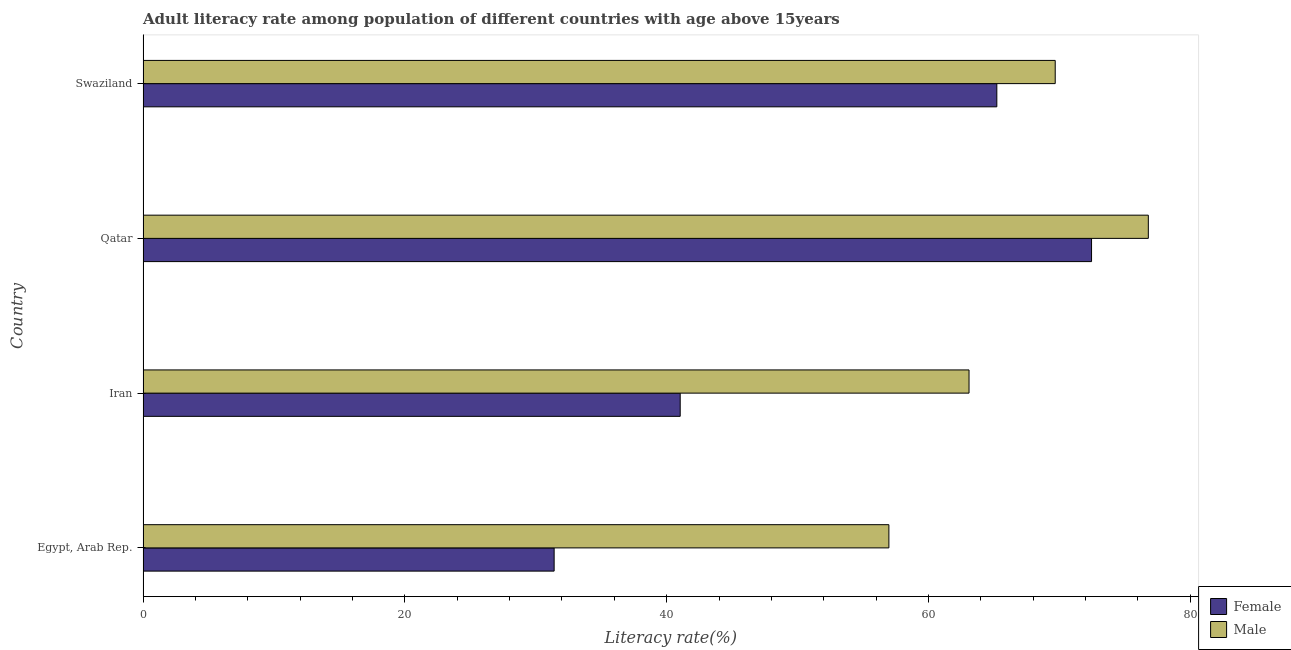How many groups of bars are there?
Your answer should be very brief. 4. Are the number of bars per tick equal to the number of legend labels?
Give a very brief answer. Yes. Are the number of bars on each tick of the Y-axis equal?
Your answer should be very brief. Yes. How many bars are there on the 3rd tick from the top?
Provide a short and direct response. 2. What is the label of the 1st group of bars from the top?
Make the answer very short. Swaziland. In how many cases, is the number of bars for a given country not equal to the number of legend labels?
Your answer should be very brief. 0. What is the female adult literacy rate in Qatar?
Your answer should be compact. 72.46. Across all countries, what is the maximum male adult literacy rate?
Provide a short and direct response. 76.8. Across all countries, what is the minimum female adult literacy rate?
Your answer should be very brief. 31.4. In which country was the female adult literacy rate maximum?
Your answer should be compact. Qatar. In which country was the male adult literacy rate minimum?
Make the answer very short. Egypt, Arab Rep. What is the total female adult literacy rate in the graph?
Provide a short and direct response. 210.12. What is the difference between the male adult literacy rate in Iran and that in Qatar?
Give a very brief answer. -13.7. What is the difference between the male adult literacy rate in Iran and the female adult literacy rate in Egypt, Arab Rep.?
Ensure brevity in your answer.  31.7. What is the average female adult literacy rate per country?
Provide a succinct answer. 52.53. What is the difference between the female adult literacy rate and male adult literacy rate in Iran?
Make the answer very short. -22.07. What is the ratio of the male adult literacy rate in Egypt, Arab Rep. to that in Swaziland?
Offer a very short reply. 0.82. Is the female adult literacy rate in Egypt, Arab Rep. less than that in Iran?
Your answer should be compact. Yes. Is the difference between the female adult literacy rate in Egypt, Arab Rep. and Qatar greater than the difference between the male adult literacy rate in Egypt, Arab Rep. and Qatar?
Offer a terse response. No. What is the difference between the highest and the second highest female adult literacy rate?
Offer a very short reply. 7.24. What is the difference between the highest and the lowest female adult literacy rate?
Offer a terse response. 41.05. In how many countries, is the female adult literacy rate greater than the average female adult literacy rate taken over all countries?
Your response must be concise. 2. What does the 1st bar from the bottom in Swaziland represents?
Provide a short and direct response. Female. How many bars are there?
Provide a succinct answer. 8. Are all the bars in the graph horizontal?
Make the answer very short. Yes. How many countries are there in the graph?
Make the answer very short. 4. What is the difference between two consecutive major ticks on the X-axis?
Keep it short and to the point. 20. Are the values on the major ticks of X-axis written in scientific E-notation?
Offer a terse response. No. Does the graph contain any zero values?
Provide a succinct answer. No. Does the graph contain grids?
Your answer should be compact. No. Where does the legend appear in the graph?
Give a very brief answer. Bottom right. How are the legend labels stacked?
Offer a very short reply. Vertical. What is the title of the graph?
Provide a short and direct response. Adult literacy rate among population of different countries with age above 15years. Does "Merchandise exports" appear as one of the legend labels in the graph?
Your answer should be very brief. No. What is the label or title of the X-axis?
Your answer should be very brief. Literacy rate(%). What is the Literacy rate(%) of Female in Egypt, Arab Rep.?
Provide a short and direct response. 31.4. What is the Literacy rate(%) in Male in Egypt, Arab Rep.?
Provide a short and direct response. 56.98. What is the Literacy rate(%) in Female in Iran?
Your response must be concise. 41.03. What is the Literacy rate(%) of Male in Iran?
Offer a terse response. 63.1. What is the Literacy rate(%) in Female in Qatar?
Offer a very short reply. 72.46. What is the Literacy rate(%) of Male in Qatar?
Make the answer very short. 76.8. What is the Literacy rate(%) in Female in Swaziland?
Ensure brevity in your answer.  65.22. What is the Literacy rate(%) of Male in Swaziland?
Ensure brevity in your answer.  69.68. Across all countries, what is the maximum Literacy rate(%) in Female?
Offer a terse response. 72.46. Across all countries, what is the maximum Literacy rate(%) in Male?
Provide a succinct answer. 76.8. Across all countries, what is the minimum Literacy rate(%) in Female?
Provide a succinct answer. 31.4. Across all countries, what is the minimum Literacy rate(%) of Male?
Give a very brief answer. 56.98. What is the total Literacy rate(%) in Female in the graph?
Keep it short and to the point. 210.12. What is the total Literacy rate(%) of Male in the graph?
Offer a very short reply. 266.56. What is the difference between the Literacy rate(%) of Female in Egypt, Arab Rep. and that in Iran?
Your response must be concise. -9.63. What is the difference between the Literacy rate(%) of Male in Egypt, Arab Rep. and that in Iran?
Give a very brief answer. -6.12. What is the difference between the Literacy rate(%) of Female in Egypt, Arab Rep. and that in Qatar?
Your answer should be compact. -41.05. What is the difference between the Literacy rate(%) in Male in Egypt, Arab Rep. and that in Qatar?
Keep it short and to the point. -19.82. What is the difference between the Literacy rate(%) in Female in Egypt, Arab Rep. and that in Swaziland?
Give a very brief answer. -33.82. What is the difference between the Literacy rate(%) of Male in Egypt, Arab Rep. and that in Swaziland?
Keep it short and to the point. -12.71. What is the difference between the Literacy rate(%) in Female in Iran and that in Qatar?
Your answer should be compact. -31.43. What is the difference between the Literacy rate(%) of Male in Iran and that in Qatar?
Your answer should be compact. -13.7. What is the difference between the Literacy rate(%) in Female in Iran and that in Swaziland?
Give a very brief answer. -24.19. What is the difference between the Literacy rate(%) in Male in Iran and that in Swaziland?
Your response must be concise. -6.58. What is the difference between the Literacy rate(%) in Female in Qatar and that in Swaziland?
Your answer should be very brief. 7.24. What is the difference between the Literacy rate(%) of Male in Qatar and that in Swaziland?
Provide a succinct answer. 7.11. What is the difference between the Literacy rate(%) in Female in Egypt, Arab Rep. and the Literacy rate(%) in Male in Iran?
Make the answer very short. -31.7. What is the difference between the Literacy rate(%) of Female in Egypt, Arab Rep. and the Literacy rate(%) of Male in Qatar?
Provide a succinct answer. -45.39. What is the difference between the Literacy rate(%) in Female in Egypt, Arab Rep. and the Literacy rate(%) in Male in Swaziland?
Provide a short and direct response. -38.28. What is the difference between the Literacy rate(%) in Female in Iran and the Literacy rate(%) in Male in Qatar?
Keep it short and to the point. -35.76. What is the difference between the Literacy rate(%) of Female in Iran and the Literacy rate(%) of Male in Swaziland?
Provide a short and direct response. -28.65. What is the difference between the Literacy rate(%) in Female in Qatar and the Literacy rate(%) in Male in Swaziland?
Offer a terse response. 2.78. What is the average Literacy rate(%) of Female per country?
Your answer should be compact. 52.53. What is the average Literacy rate(%) of Male per country?
Your answer should be very brief. 66.64. What is the difference between the Literacy rate(%) of Female and Literacy rate(%) of Male in Egypt, Arab Rep.?
Your answer should be compact. -25.57. What is the difference between the Literacy rate(%) in Female and Literacy rate(%) in Male in Iran?
Provide a short and direct response. -22.07. What is the difference between the Literacy rate(%) in Female and Literacy rate(%) in Male in Qatar?
Your response must be concise. -4.34. What is the difference between the Literacy rate(%) in Female and Literacy rate(%) in Male in Swaziland?
Offer a terse response. -4.46. What is the ratio of the Literacy rate(%) in Female in Egypt, Arab Rep. to that in Iran?
Your answer should be compact. 0.77. What is the ratio of the Literacy rate(%) of Male in Egypt, Arab Rep. to that in Iran?
Provide a succinct answer. 0.9. What is the ratio of the Literacy rate(%) in Female in Egypt, Arab Rep. to that in Qatar?
Your answer should be very brief. 0.43. What is the ratio of the Literacy rate(%) in Male in Egypt, Arab Rep. to that in Qatar?
Give a very brief answer. 0.74. What is the ratio of the Literacy rate(%) in Female in Egypt, Arab Rep. to that in Swaziland?
Your response must be concise. 0.48. What is the ratio of the Literacy rate(%) of Male in Egypt, Arab Rep. to that in Swaziland?
Give a very brief answer. 0.82. What is the ratio of the Literacy rate(%) in Female in Iran to that in Qatar?
Provide a succinct answer. 0.57. What is the ratio of the Literacy rate(%) of Male in Iran to that in Qatar?
Provide a short and direct response. 0.82. What is the ratio of the Literacy rate(%) in Female in Iran to that in Swaziland?
Your answer should be compact. 0.63. What is the ratio of the Literacy rate(%) of Male in Iran to that in Swaziland?
Offer a terse response. 0.91. What is the ratio of the Literacy rate(%) in Female in Qatar to that in Swaziland?
Give a very brief answer. 1.11. What is the ratio of the Literacy rate(%) of Male in Qatar to that in Swaziland?
Your answer should be very brief. 1.1. What is the difference between the highest and the second highest Literacy rate(%) in Female?
Provide a short and direct response. 7.24. What is the difference between the highest and the second highest Literacy rate(%) of Male?
Give a very brief answer. 7.11. What is the difference between the highest and the lowest Literacy rate(%) of Female?
Your answer should be compact. 41.05. What is the difference between the highest and the lowest Literacy rate(%) in Male?
Your answer should be compact. 19.82. 